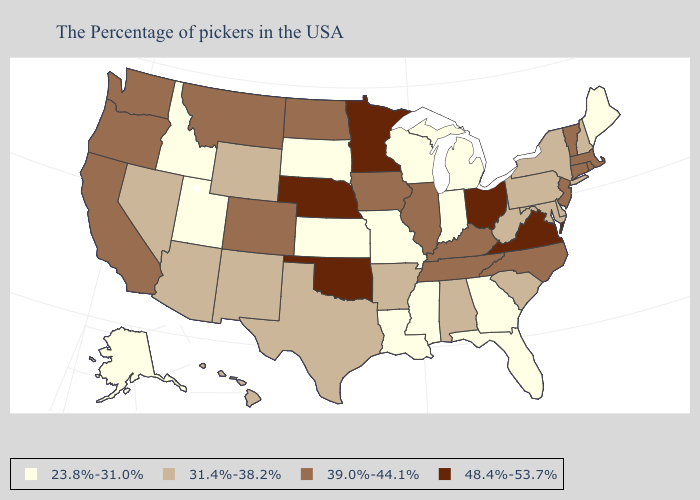Does Vermont have a higher value than Tennessee?
Keep it brief. No. Name the states that have a value in the range 39.0%-44.1%?
Short answer required. Massachusetts, Rhode Island, Vermont, Connecticut, New Jersey, North Carolina, Kentucky, Tennessee, Illinois, Iowa, North Dakota, Colorado, Montana, California, Washington, Oregon. What is the value of Minnesota?
Be succinct. 48.4%-53.7%. Among the states that border Texas , does Louisiana have the highest value?
Concise answer only. No. Name the states that have a value in the range 48.4%-53.7%?
Answer briefly. Virginia, Ohio, Minnesota, Nebraska, Oklahoma. Which states have the lowest value in the USA?
Be succinct. Maine, Florida, Georgia, Michigan, Indiana, Wisconsin, Mississippi, Louisiana, Missouri, Kansas, South Dakota, Utah, Idaho, Alaska. Which states have the lowest value in the Northeast?
Give a very brief answer. Maine. Among the states that border West Virginia , which have the lowest value?
Concise answer only. Maryland, Pennsylvania. What is the value of New Jersey?
Be succinct. 39.0%-44.1%. Name the states that have a value in the range 48.4%-53.7%?
Short answer required. Virginia, Ohio, Minnesota, Nebraska, Oklahoma. What is the value of Illinois?
Be succinct. 39.0%-44.1%. Name the states that have a value in the range 48.4%-53.7%?
Keep it brief. Virginia, Ohio, Minnesota, Nebraska, Oklahoma. Does Idaho have a higher value than Maine?
Be succinct. No. Among the states that border Maryland , does Delaware have the highest value?
Answer briefly. No. What is the highest value in the USA?
Quick response, please. 48.4%-53.7%. 